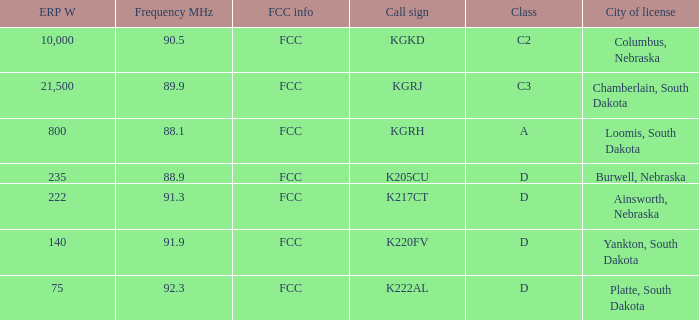What is the highest erp w with a 90.5 frequency mhz? 10000.0. 